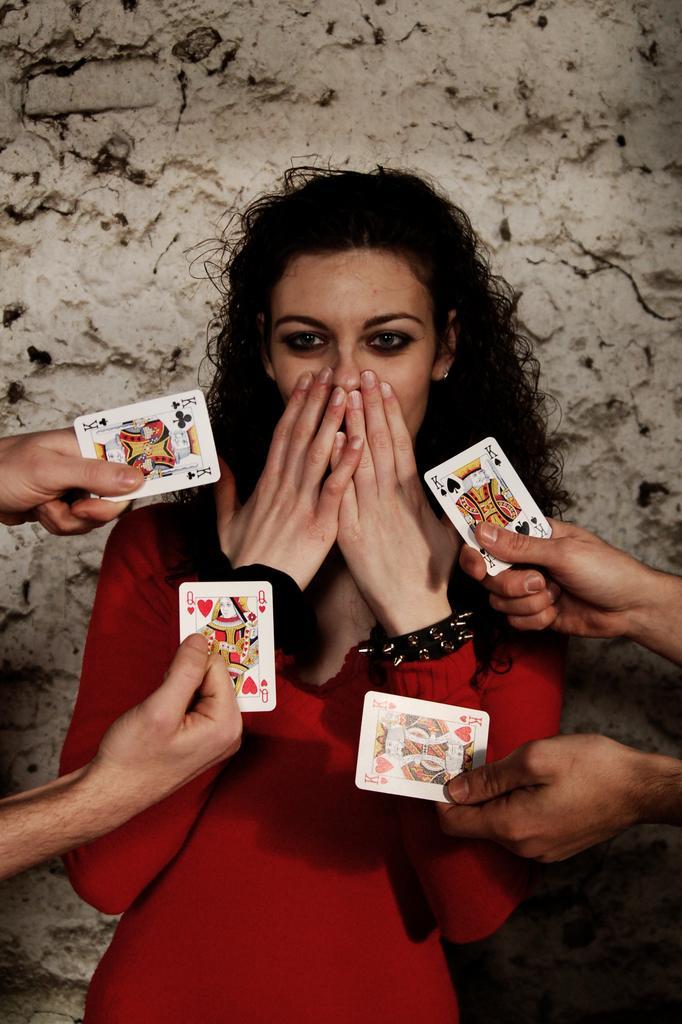Can you describe this image briefly? As we can see in the image there is a white wall. In Front of that there is a woman standing and she is closing her mouth with her hands. There are four hands in front of her who are holding playing cards and the woman is wearing red dress. 